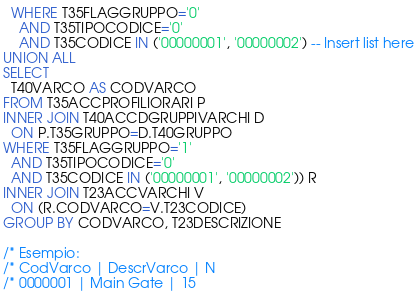Convert code to text. <code><loc_0><loc_0><loc_500><loc_500><_SQL_>  WHERE T35FLAGGRUPPO='0' 
    AND T35TIPOCODICE='0' 
    AND T35CODICE IN ('00000001', '00000002') -- Insert list here
UNION ALL
SELECT 
  T40VARCO AS CODVARCO
FROM T35ACCPROFILIORARI P
INNER JOIN T40ACCDGRUPPIVARCHI D
  ON P.T35GRUPPO=D.T40GRUPPO
WHERE T35FLAGGRUPPO='1' 
  AND T35TIPOCODICE='0' 
  AND T35CODICE IN ('00000001', '00000002')) R
INNER JOIN T23ACCVARCHI V
  ON (R.CODVARCO=V.T23CODICE)
GROUP BY CODVARCO, T23DESCRIZIONE

/* Esempio:
/* CodVarco | DescrVarco | N
/* 0000001 | Main Gate | 15
</code> 